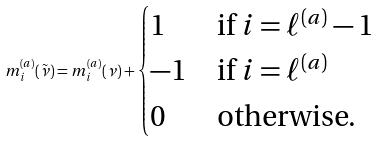<formula> <loc_0><loc_0><loc_500><loc_500>m _ { i } ^ { ( a ) } ( \tilde { \nu } ) = m _ { i } ^ { ( a ) } ( \nu ) + \begin{cases} 1 & \text {if $i=\ell^{(a)}-1$} \\ - 1 & \text {if $i=\ell^{(a)}$} \\ 0 & \text {otherwise.} \end{cases}</formula> 